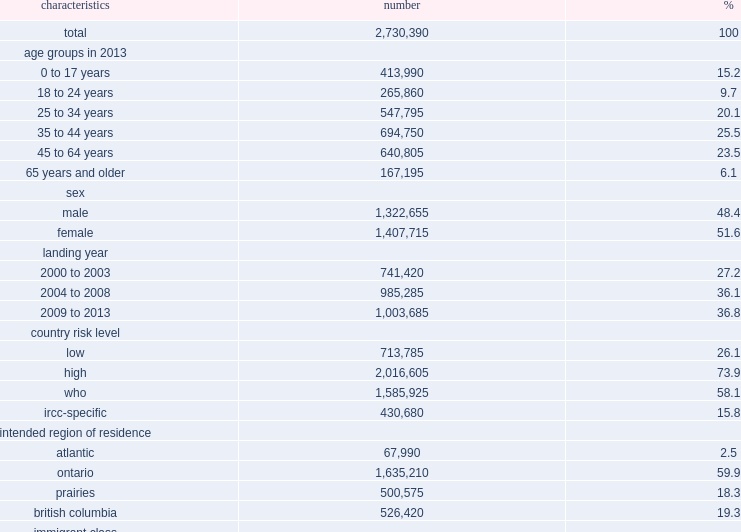What was the total number of immigrants who arrived in canada from 2000 to 2013? 2730390.0. What was the percentage of female immigrants in the study cohort? 51.6. What was the percentage of 25 to 44 years'immigrants in the study cohort? 45.6. What was the percentage of countries on the ircc designated list for tb? 73.9. What was the percentage of the who high tb-burden list of ircc designated list country risk level? 58.1. What was the percentage of the ircc-specific countries risk level? 15.8. Which country did most immigrants intend to reside in? Ontario. What was the majority of the cohort arrived as immigrants class? 59. What was the percentage of the cohort arrived as immigrants in the family category? 28.0. What was the percentage of the cohort arrived as immigrants in the refugee category? 10.6. 